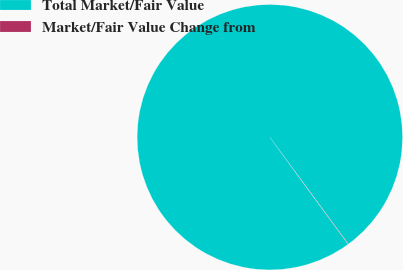Convert chart to OTSL. <chart><loc_0><loc_0><loc_500><loc_500><pie_chart><fcel>Total Market/Fair Value<fcel>Market/Fair Value Change from<nl><fcel>99.96%<fcel>0.04%<nl></chart> 